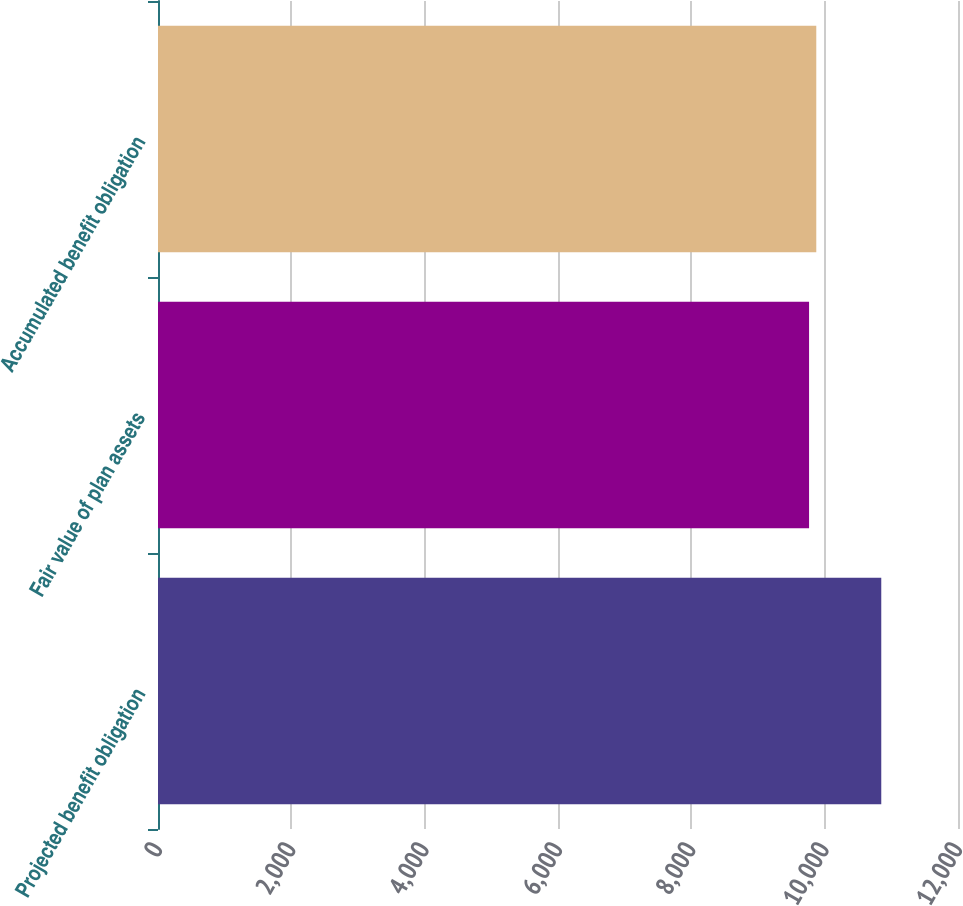Convert chart. <chart><loc_0><loc_0><loc_500><loc_500><bar_chart><fcel>Projected benefit obligation<fcel>Fair value of plan assets<fcel>Accumulated benefit obligation<nl><fcel>10849<fcel>9766<fcel>9874.3<nl></chart> 